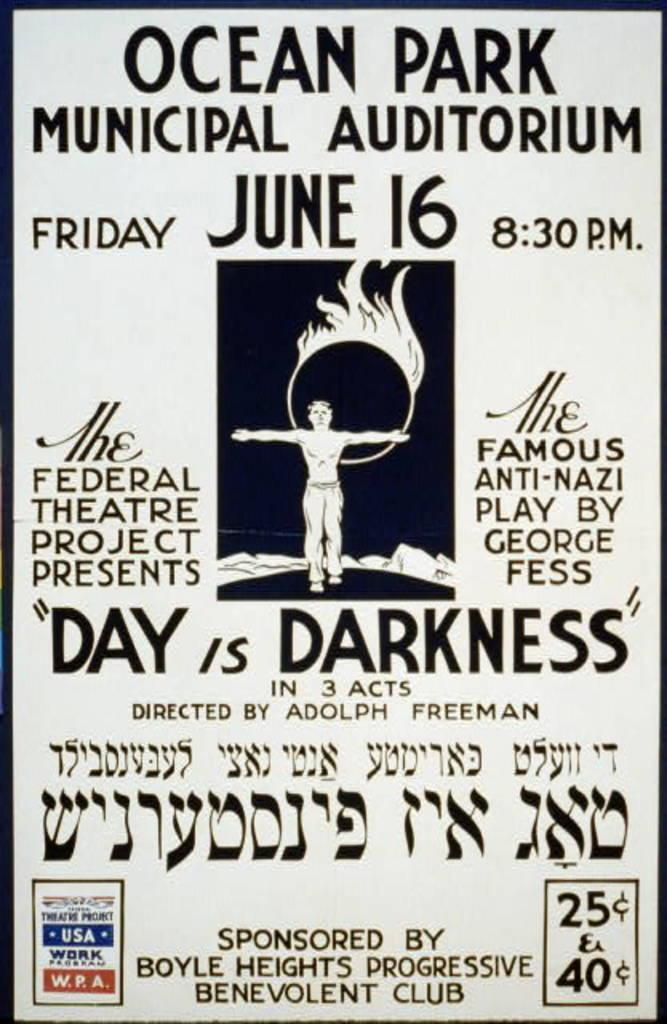<image>
Provide a brief description of the given image. A black and white poster for Ocean Park Municipal Auditorium 